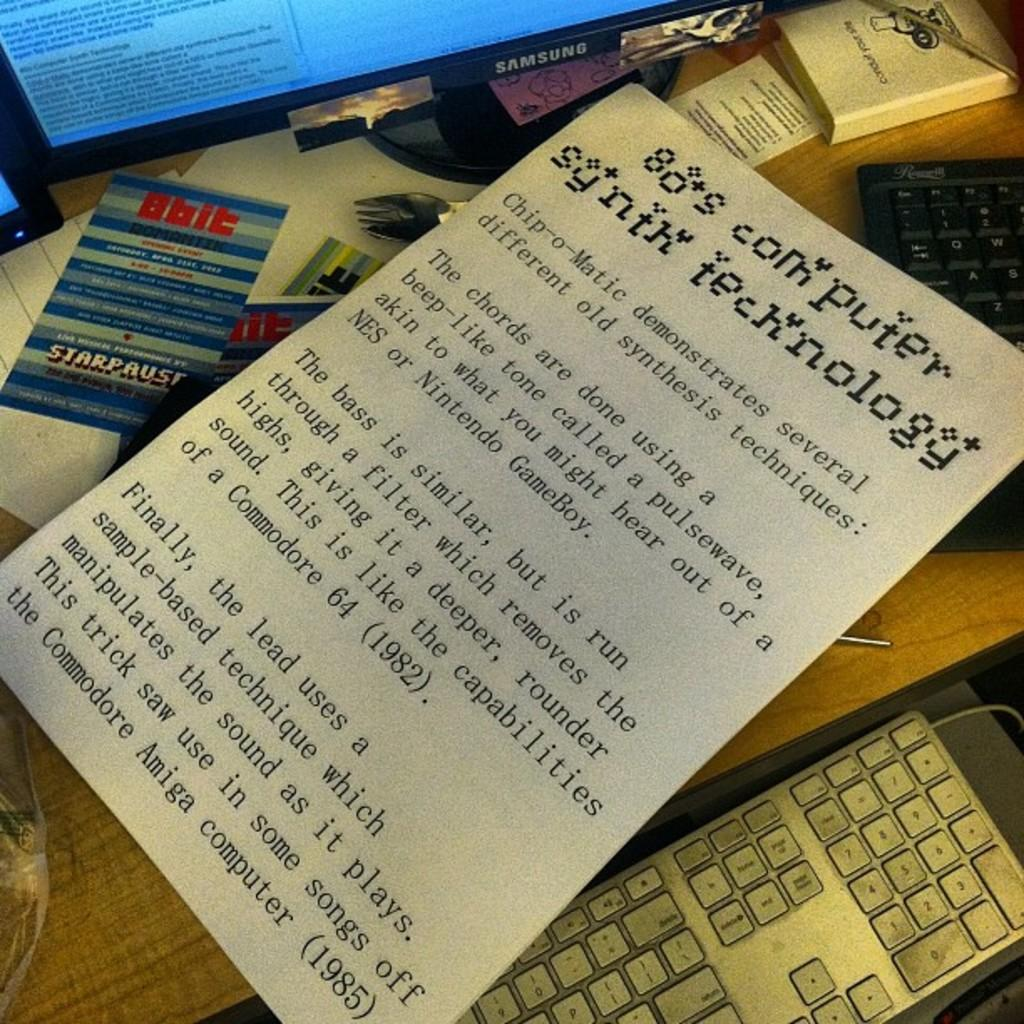<image>
Create a compact narrative representing the image presented. A page that has printed writing about 80's computers. 